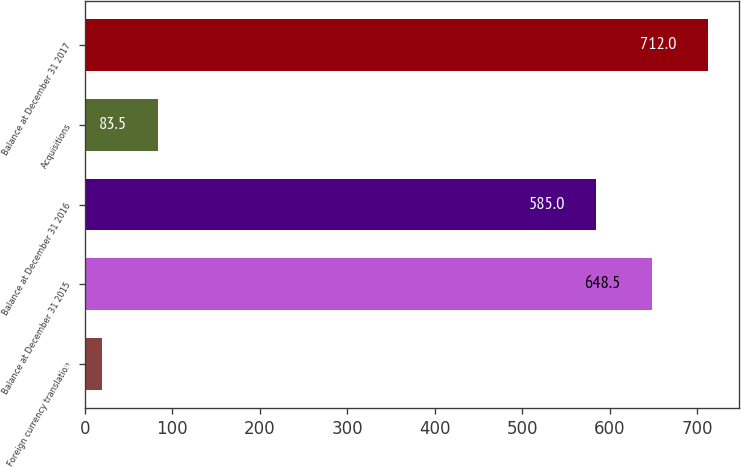Convert chart to OTSL. <chart><loc_0><loc_0><loc_500><loc_500><bar_chart><fcel>Foreign currency translation<fcel>Balance at December 31 2015<fcel>Balance at December 31 2016<fcel>Acquisitions<fcel>Balance at December 31 2017<nl><fcel>20<fcel>648.5<fcel>585<fcel>83.5<fcel>712<nl></chart> 